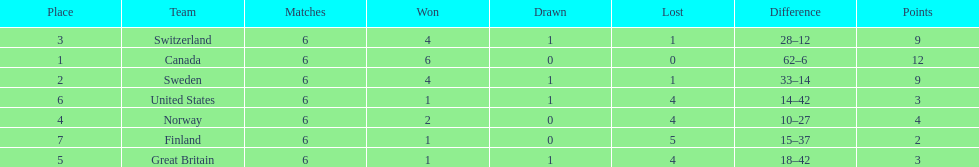Between finland and norway, which team has a higher number of match victories? Norway. 